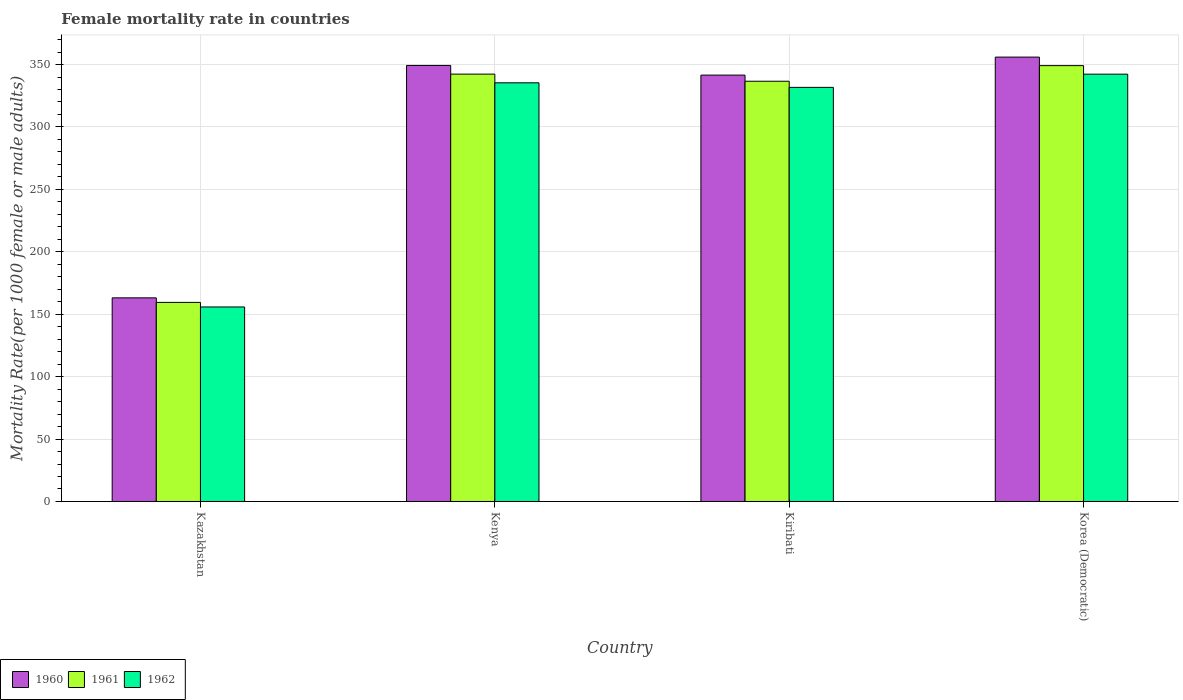How many different coloured bars are there?
Your response must be concise. 3. How many groups of bars are there?
Provide a short and direct response. 4. Are the number of bars per tick equal to the number of legend labels?
Give a very brief answer. Yes. How many bars are there on the 4th tick from the left?
Offer a very short reply. 3. How many bars are there on the 2nd tick from the right?
Make the answer very short. 3. What is the label of the 4th group of bars from the left?
Your answer should be compact. Korea (Democratic). What is the female mortality rate in 1960 in Korea (Democratic)?
Your answer should be compact. 355.97. Across all countries, what is the maximum female mortality rate in 1960?
Make the answer very short. 355.97. Across all countries, what is the minimum female mortality rate in 1962?
Your answer should be very brief. 155.82. In which country was the female mortality rate in 1960 maximum?
Provide a succinct answer. Korea (Democratic). In which country was the female mortality rate in 1962 minimum?
Provide a succinct answer. Kazakhstan. What is the total female mortality rate in 1960 in the graph?
Your answer should be compact. 1209.92. What is the difference between the female mortality rate in 1960 in Kazakhstan and that in Korea (Democratic)?
Offer a terse response. -192.85. What is the difference between the female mortality rate in 1962 in Kazakhstan and the female mortality rate in 1960 in Korea (Democratic)?
Give a very brief answer. -200.15. What is the average female mortality rate in 1961 per country?
Provide a succinct answer. 296.89. What is the difference between the female mortality rate of/in 1962 and female mortality rate of/in 1961 in Kiribati?
Ensure brevity in your answer.  -4.91. What is the ratio of the female mortality rate in 1961 in Kazakhstan to that in Kenya?
Your answer should be compact. 0.47. Is the difference between the female mortality rate in 1962 in Kenya and Korea (Democratic) greater than the difference between the female mortality rate in 1961 in Kenya and Korea (Democratic)?
Ensure brevity in your answer.  No. What is the difference between the highest and the second highest female mortality rate in 1962?
Provide a succinct answer. -10.57. What is the difference between the highest and the lowest female mortality rate in 1962?
Keep it short and to the point. 186.47. Is the sum of the female mortality rate in 1962 in Kazakhstan and Korea (Democratic) greater than the maximum female mortality rate in 1960 across all countries?
Offer a terse response. Yes. What does the 1st bar from the left in Kenya represents?
Give a very brief answer. 1960. Is it the case that in every country, the sum of the female mortality rate in 1961 and female mortality rate in 1960 is greater than the female mortality rate in 1962?
Ensure brevity in your answer.  Yes. How many bars are there?
Ensure brevity in your answer.  12. How many countries are there in the graph?
Keep it short and to the point. 4. What is the difference between two consecutive major ticks on the Y-axis?
Provide a succinct answer. 50. Does the graph contain any zero values?
Make the answer very short. No. What is the title of the graph?
Give a very brief answer. Female mortality rate in countries. What is the label or title of the X-axis?
Ensure brevity in your answer.  Country. What is the label or title of the Y-axis?
Keep it short and to the point. Mortality Rate(per 1000 female or male adults). What is the Mortality Rate(per 1000 female or male adults) in 1960 in Kazakhstan?
Your answer should be compact. 163.12. What is the Mortality Rate(per 1000 female or male adults) of 1961 in Kazakhstan?
Give a very brief answer. 159.47. What is the Mortality Rate(per 1000 female or male adults) in 1962 in Kazakhstan?
Keep it short and to the point. 155.82. What is the Mortality Rate(per 1000 female or male adults) of 1960 in Kenya?
Keep it short and to the point. 349.28. What is the Mortality Rate(per 1000 female or male adults) of 1961 in Kenya?
Ensure brevity in your answer.  342.33. What is the Mortality Rate(per 1000 female or male adults) of 1962 in Kenya?
Provide a succinct answer. 335.38. What is the Mortality Rate(per 1000 female or male adults) in 1960 in Kiribati?
Offer a terse response. 341.55. What is the Mortality Rate(per 1000 female or male adults) in 1961 in Kiribati?
Keep it short and to the point. 336.63. What is the Mortality Rate(per 1000 female or male adults) of 1962 in Kiribati?
Provide a short and direct response. 331.72. What is the Mortality Rate(per 1000 female or male adults) of 1960 in Korea (Democratic)?
Provide a succinct answer. 355.97. What is the Mortality Rate(per 1000 female or male adults) in 1961 in Korea (Democratic)?
Offer a terse response. 349.13. What is the Mortality Rate(per 1000 female or male adults) of 1962 in Korea (Democratic)?
Make the answer very short. 342.29. Across all countries, what is the maximum Mortality Rate(per 1000 female or male adults) in 1960?
Offer a very short reply. 355.97. Across all countries, what is the maximum Mortality Rate(per 1000 female or male adults) of 1961?
Offer a very short reply. 349.13. Across all countries, what is the maximum Mortality Rate(per 1000 female or male adults) in 1962?
Offer a terse response. 342.29. Across all countries, what is the minimum Mortality Rate(per 1000 female or male adults) in 1960?
Keep it short and to the point. 163.12. Across all countries, what is the minimum Mortality Rate(per 1000 female or male adults) of 1961?
Your answer should be compact. 159.47. Across all countries, what is the minimum Mortality Rate(per 1000 female or male adults) of 1962?
Your answer should be very brief. 155.82. What is the total Mortality Rate(per 1000 female or male adults) in 1960 in the graph?
Make the answer very short. 1209.92. What is the total Mortality Rate(per 1000 female or male adults) in 1961 in the graph?
Keep it short and to the point. 1187.56. What is the total Mortality Rate(per 1000 female or male adults) in 1962 in the graph?
Provide a succinct answer. 1165.21. What is the difference between the Mortality Rate(per 1000 female or male adults) of 1960 in Kazakhstan and that in Kenya?
Provide a short and direct response. -186.16. What is the difference between the Mortality Rate(per 1000 female or male adults) in 1961 in Kazakhstan and that in Kenya?
Make the answer very short. -182.86. What is the difference between the Mortality Rate(per 1000 female or male adults) of 1962 in Kazakhstan and that in Kenya?
Your answer should be very brief. -179.56. What is the difference between the Mortality Rate(per 1000 female or male adults) of 1960 in Kazakhstan and that in Kiribati?
Your response must be concise. -178.43. What is the difference between the Mortality Rate(per 1000 female or male adults) in 1961 in Kazakhstan and that in Kiribati?
Ensure brevity in your answer.  -177.16. What is the difference between the Mortality Rate(per 1000 female or male adults) of 1962 in Kazakhstan and that in Kiribati?
Make the answer very short. -175.9. What is the difference between the Mortality Rate(per 1000 female or male adults) of 1960 in Kazakhstan and that in Korea (Democratic)?
Give a very brief answer. -192.85. What is the difference between the Mortality Rate(per 1000 female or male adults) of 1961 in Kazakhstan and that in Korea (Democratic)?
Provide a succinct answer. -189.66. What is the difference between the Mortality Rate(per 1000 female or male adults) of 1962 in Kazakhstan and that in Korea (Democratic)?
Give a very brief answer. -186.47. What is the difference between the Mortality Rate(per 1000 female or male adults) of 1960 in Kenya and that in Kiribati?
Provide a succinct answer. 7.74. What is the difference between the Mortality Rate(per 1000 female or male adults) in 1961 in Kenya and that in Kiribati?
Provide a short and direct response. 5.7. What is the difference between the Mortality Rate(per 1000 female or male adults) in 1962 in Kenya and that in Kiribati?
Make the answer very short. 3.66. What is the difference between the Mortality Rate(per 1000 female or male adults) in 1960 in Kenya and that in Korea (Democratic)?
Your answer should be compact. -6.69. What is the difference between the Mortality Rate(per 1000 female or male adults) of 1961 in Kenya and that in Korea (Democratic)?
Make the answer very short. -6.8. What is the difference between the Mortality Rate(per 1000 female or male adults) of 1962 in Kenya and that in Korea (Democratic)?
Your answer should be very brief. -6.91. What is the difference between the Mortality Rate(per 1000 female or male adults) of 1960 in Kiribati and that in Korea (Democratic)?
Ensure brevity in your answer.  -14.43. What is the difference between the Mortality Rate(per 1000 female or male adults) in 1961 in Kiribati and that in Korea (Democratic)?
Offer a very short reply. -12.5. What is the difference between the Mortality Rate(per 1000 female or male adults) of 1962 in Kiribati and that in Korea (Democratic)?
Provide a succinct answer. -10.57. What is the difference between the Mortality Rate(per 1000 female or male adults) in 1960 in Kazakhstan and the Mortality Rate(per 1000 female or male adults) in 1961 in Kenya?
Offer a very short reply. -179.21. What is the difference between the Mortality Rate(per 1000 female or male adults) of 1960 in Kazakhstan and the Mortality Rate(per 1000 female or male adults) of 1962 in Kenya?
Provide a short and direct response. -172.26. What is the difference between the Mortality Rate(per 1000 female or male adults) in 1961 in Kazakhstan and the Mortality Rate(per 1000 female or male adults) in 1962 in Kenya?
Provide a short and direct response. -175.91. What is the difference between the Mortality Rate(per 1000 female or male adults) of 1960 in Kazakhstan and the Mortality Rate(per 1000 female or male adults) of 1961 in Kiribati?
Offer a terse response. -173.51. What is the difference between the Mortality Rate(per 1000 female or male adults) of 1960 in Kazakhstan and the Mortality Rate(per 1000 female or male adults) of 1962 in Kiribati?
Make the answer very short. -168.6. What is the difference between the Mortality Rate(per 1000 female or male adults) of 1961 in Kazakhstan and the Mortality Rate(per 1000 female or male adults) of 1962 in Kiribati?
Offer a terse response. -172.25. What is the difference between the Mortality Rate(per 1000 female or male adults) of 1960 in Kazakhstan and the Mortality Rate(per 1000 female or male adults) of 1961 in Korea (Democratic)?
Your response must be concise. -186.01. What is the difference between the Mortality Rate(per 1000 female or male adults) in 1960 in Kazakhstan and the Mortality Rate(per 1000 female or male adults) in 1962 in Korea (Democratic)?
Give a very brief answer. -179.17. What is the difference between the Mortality Rate(per 1000 female or male adults) of 1961 in Kazakhstan and the Mortality Rate(per 1000 female or male adults) of 1962 in Korea (Democratic)?
Your response must be concise. -182.82. What is the difference between the Mortality Rate(per 1000 female or male adults) in 1960 in Kenya and the Mortality Rate(per 1000 female or male adults) in 1961 in Kiribati?
Ensure brevity in your answer.  12.65. What is the difference between the Mortality Rate(per 1000 female or male adults) of 1960 in Kenya and the Mortality Rate(per 1000 female or male adults) of 1962 in Kiribati?
Your answer should be compact. 17.57. What is the difference between the Mortality Rate(per 1000 female or male adults) of 1961 in Kenya and the Mortality Rate(per 1000 female or male adults) of 1962 in Kiribati?
Your response must be concise. 10.61. What is the difference between the Mortality Rate(per 1000 female or male adults) of 1960 in Kenya and the Mortality Rate(per 1000 female or male adults) of 1962 in Korea (Democratic)?
Make the answer very short. 6.99. What is the difference between the Mortality Rate(per 1000 female or male adults) of 1961 in Kenya and the Mortality Rate(per 1000 female or male adults) of 1962 in Korea (Democratic)?
Make the answer very short. 0.04. What is the difference between the Mortality Rate(per 1000 female or male adults) of 1960 in Kiribati and the Mortality Rate(per 1000 female or male adults) of 1961 in Korea (Democratic)?
Your response must be concise. -7.59. What is the difference between the Mortality Rate(per 1000 female or male adults) of 1960 in Kiribati and the Mortality Rate(per 1000 female or male adults) of 1962 in Korea (Democratic)?
Make the answer very short. -0.75. What is the difference between the Mortality Rate(per 1000 female or male adults) of 1961 in Kiribati and the Mortality Rate(per 1000 female or male adults) of 1962 in Korea (Democratic)?
Offer a terse response. -5.66. What is the average Mortality Rate(per 1000 female or male adults) in 1960 per country?
Provide a succinct answer. 302.48. What is the average Mortality Rate(per 1000 female or male adults) of 1961 per country?
Keep it short and to the point. 296.89. What is the average Mortality Rate(per 1000 female or male adults) of 1962 per country?
Make the answer very short. 291.3. What is the difference between the Mortality Rate(per 1000 female or male adults) in 1960 and Mortality Rate(per 1000 female or male adults) in 1961 in Kazakhstan?
Your response must be concise. 3.65. What is the difference between the Mortality Rate(per 1000 female or male adults) in 1960 and Mortality Rate(per 1000 female or male adults) in 1962 in Kazakhstan?
Your answer should be compact. 7.3. What is the difference between the Mortality Rate(per 1000 female or male adults) in 1961 and Mortality Rate(per 1000 female or male adults) in 1962 in Kazakhstan?
Your answer should be very brief. 3.65. What is the difference between the Mortality Rate(per 1000 female or male adults) of 1960 and Mortality Rate(per 1000 female or male adults) of 1961 in Kenya?
Provide a succinct answer. 6.95. What is the difference between the Mortality Rate(per 1000 female or male adults) in 1960 and Mortality Rate(per 1000 female or male adults) in 1962 in Kenya?
Make the answer very short. 13.9. What is the difference between the Mortality Rate(per 1000 female or male adults) of 1961 and Mortality Rate(per 1000 female or male adults) of 1962 in Kenya?
Your response must be concise. 6.95. What is the difference between the Mortality Rate(per 1000 female or male adults) in 1960 and Mortality Rate(per 1000 female or male adults) in 1961 in Kiribati?
Make the answer very short. 4.91. What is the difference between the Mortality Rate(per 1000 female or male adults) of 1960 and Mortality Rate(per 1000 female or male adults) of 1962 in Kiribati?
Offer a very short reply. 9.83. What is the difference between the Mortality Rate(per 1000 female or male adults) in 1961 and Mortality Rate(per 1000 female or male adults) in 1962 in Kiribati?
Provide a short and direct response. 4.91. What is the difference between the Mortality Rate(per 1000 female or male adults) of 1960 and Mortality Rate(per 1000 female or male adults) of 1961 in Korea (Democratic)?
Provide a short and direct response. 6.84. What is the difference between the Mortality Rate(per 1000 female or male adults) in 1960 and Mortality Rate(per 1000 female or male adults) in 1962 in Korea (Democratic)?
Ensure brevity in your answer.  13.68. What is the difference between the Mortality Rate(per 1000 female or male adults) in 1961 and Mortality Rate(per 1000 female or male adults) in 1962 in Korea (Democratic)?
Provide a succinct answer. 6.84. What is the ratio of the Mortality Rate(per 1000 female or male adults) of 1960 in Kazakhstan to that in Kenya?
Ensure brevity in your answer.  0.47. What is the ratio of the Mortality Rate(per 1000 female or male adults) in 1961 in Kazakhstan to that in Kenya?
Offer a terse response. 0.47. What is the ratio of the Mortality Rate(per 1000 female or male adults) of 1962 in Kazakhstan to that in Kenya?
Offer a terse response. 0.46. What is the ratio of the Mortality Rate(per 1000 female or male adults) in 1960 in Kazakhstan to that in Kiribati?
Keep it short and to the point. 0.48. What is the ratio of the Mortality Rate(per 1000 female or male adults) of 1961 in Kazakhstan to that in Kiribati?
Your response must be concise. 0.47. What is the ratio of the Mortality Rate(per 1000 female or male adults) of 1962 in Kazakhstan to that in Kiribati?
Make the answer very short. 0.47. What is the ratio of the Mortality Rate(per 1000 female or male adults) of 1960 in Kazakhstan to that in Korea (Democratic)?
Make the answer very short. 0.46. What is the ratio of the Mortality Rate(per 1000 female or male adults) of 1961 in Kazakhstan to that in Korea (Democratic)?
Ensure brevity in your answer.  0.46. What is the ratio of the Mortality Rate(per 1000 female or male adults) of 1962 in Kazakhstan to that in Korea (Democratic)?
Offer a very short reply. 0.46. What is the ratio of the Mortality Rate(per 1000 female or male adults) of 1960 in Kenya to that in Kiribati?
Keep it short and to the point. 1.02. What is the ratio of the Mortality Rate(per 1000 female or male adults) of 1961 in Kenya to that in Kiribati?
Make the answer very short. 1.02. What is the ratio of the Mortality Rate(per 1000 female or male adults) of 1962 in Kenya to that in Kiribati?
Your answer should be compact. 1.01. What is the ratio of the Mortality Rate(per 1000 female or male adults) of 1960 in Kenya to that in Korea (Democratic)?
Your answer should be compact. 0.98. What is the ratio of the Mortality Rate(per 1000 female or male adults) of 1961 in Kenya to that in Korea (Democratic)?
Make the answer very short. 0.98. What is the ratio of the Mortality Rate(per 1000 female or male adults) in 1962 in Kenya to that in Korea (Democratic)?
Your answer should be very brief. 0.98. What is the ratio of the Mortality Rate(per 1000 female or male adults) of 1960 in Kiribati to that in Korea (Democratic)?
Keep it short and to the point. 0.96. What is the ratio of the Mortality Rate(per 1000 female or male adults) in 1961 in Kiribati to that in Korea (Democratic)?
Offer a very short reply. 0.96. What is the ratio of the Mortality Rate(per 1000 female or male adults) in 1962 in Kiribati to that in Korea (Democratic)?
Offer a very short reply. 0.97. What is the difference between the highest and the second highest Mortality Rate(per 1000 female or male adults) in 1960?
Your response must be concise. 6.69. What is the difference between the highest and the second highest Mortality Rate(per 1000 female or male adults) in 1961?
Provide a succinct answer. 6.8. What is the difference between the highest and the second highest Mortality Rate(per 1000 female or male adults) of 1962?
Offer a terse response. 6.91. What is the difference between the highest and the lowest Mortality Rate(per 1000 female or male adults) in 1960?
Offer a terse response. 192.85. What is the difference between the highest and the lowest Mortality Rate(per 1000 female or male adults) of 1961?
Ensure brevity in your answer.  189.66. What is the difference between the highest and the lowest Mortality Rate(per 1000 female or male adults) in 1962?
Your answer should be very brief. 186.47. 